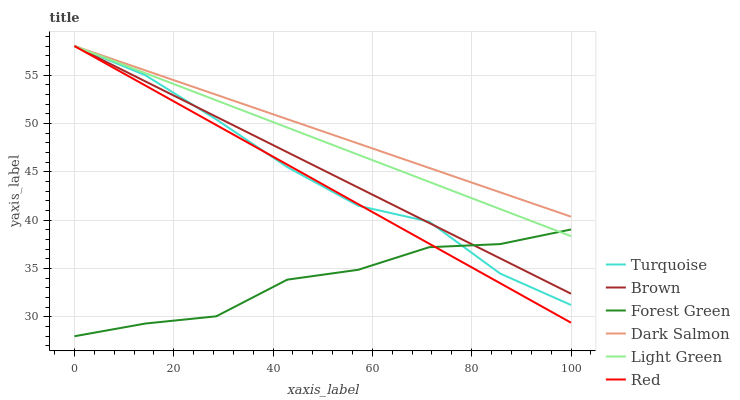Does Turquoise have the minimum area under the curve?
Answer yes or no. No. Does Turquoise have the maximum area under the curve?
Answer yes or no. No. Is Dark Salmon the smoothest?
Answer yes or no. No. Is Dark Salmon the roughest?
Answer yes or no. No. Does Turquoise have the lowest value?
Answer yes or no. No. Does Forest Green have the highest value?
Answer yes or no. No. Is Forest Green less than Dark Salmon?
Answer yes or no. Yes. Is Dark Salmon greater than Forest Green?
Answer yes or no. Yes. Does Forest Green intersect Dark Salmon?
Answer yes or no. No. 